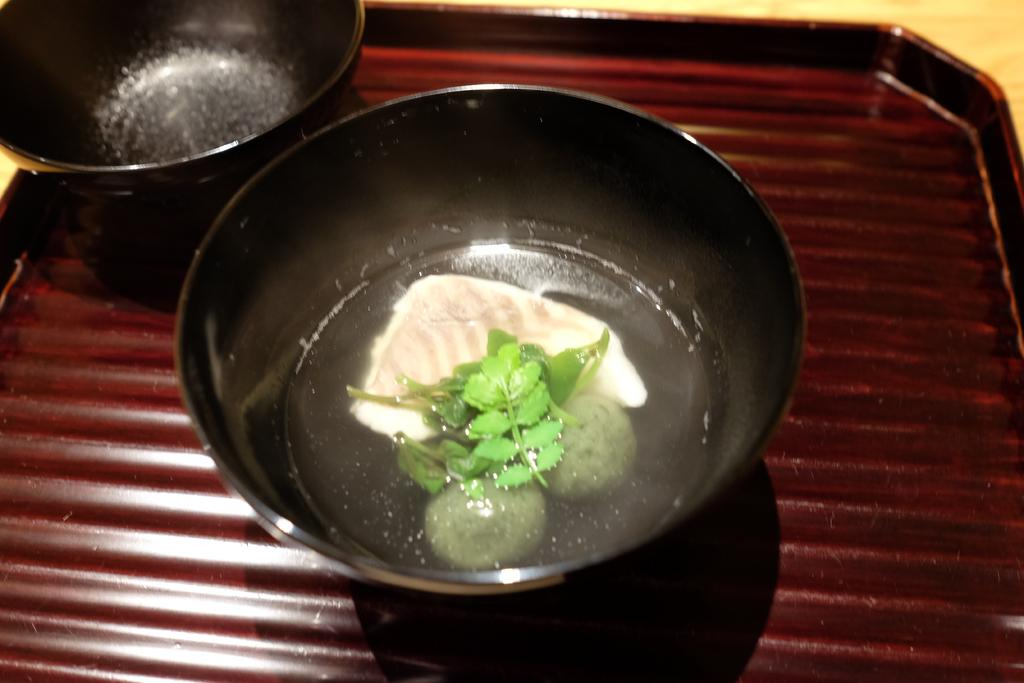What color is the bowl in the image? The bowl in the image is black. What is inside the black bowl? The black bowl contains water. What can be found in the water inside the bowl? There is a fish piece and other food items in the water. Where is the pan located in the image? The pan is in the top left corner of the image. How is the pan positioned in the image? The pan is on a tray. What is visible in the top right corner of the image? There is a table in the top right corner of the image. What type of wood is the fish piece made of in the image? The image does not provide information about the material or type of wood the fish piece is made of, as it only shows a fish piece in the water. 